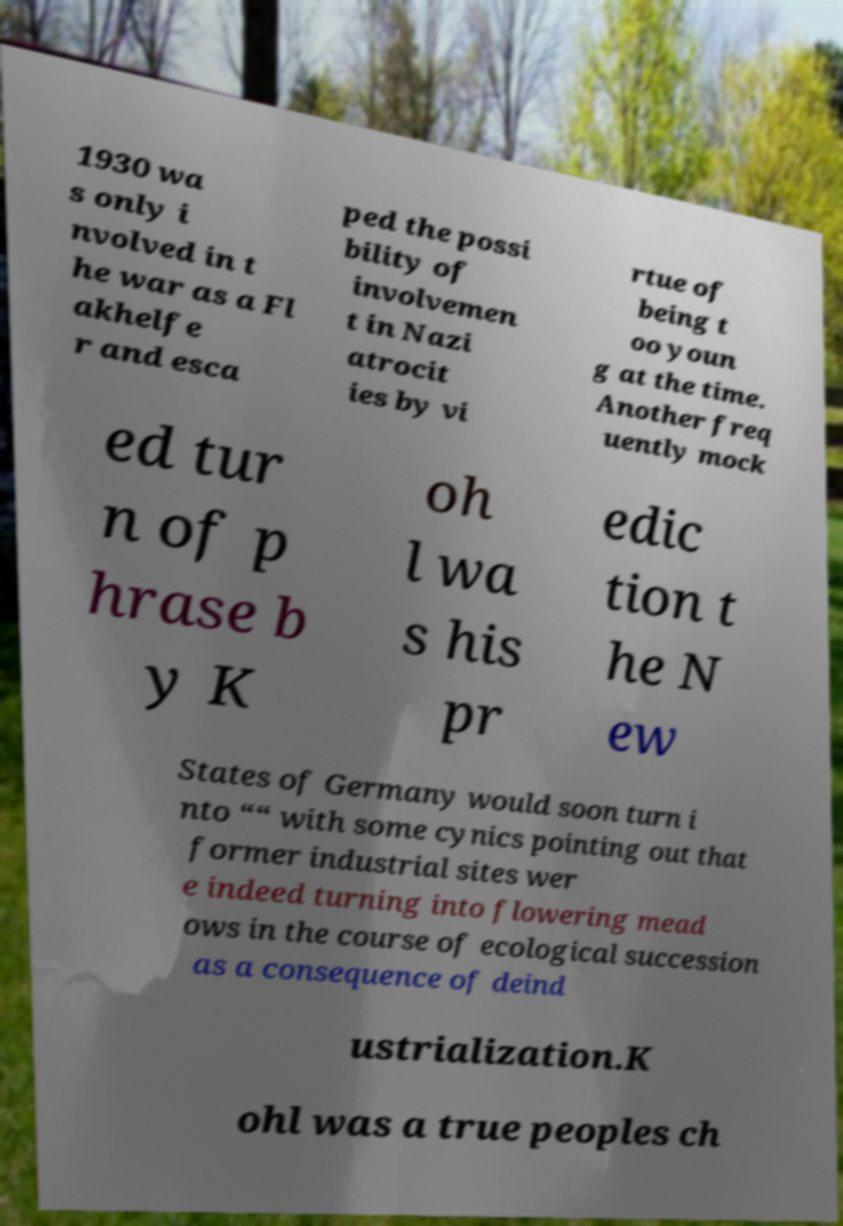What messages or text are displayed in this image? I need them in a readable, typed format. 1930 wa s only i nvolved in t he war as a Fl akhelfe r and esca ped the possi bility of involvemen t in Nazi atrocit ies by vi rtue of being t oo youn g at the time. Another freq uently mock ed tur n of p hrase b y K oh l wa s his pr edic tion t he N ew States of Germany would soon turn i nto ““ with some cynics pointing out that former industrial sites wer e indeed turning into flowering mead ows in the course of ecological succession as a consequence of deind ustrialization.K ohl was a true peoples ch 